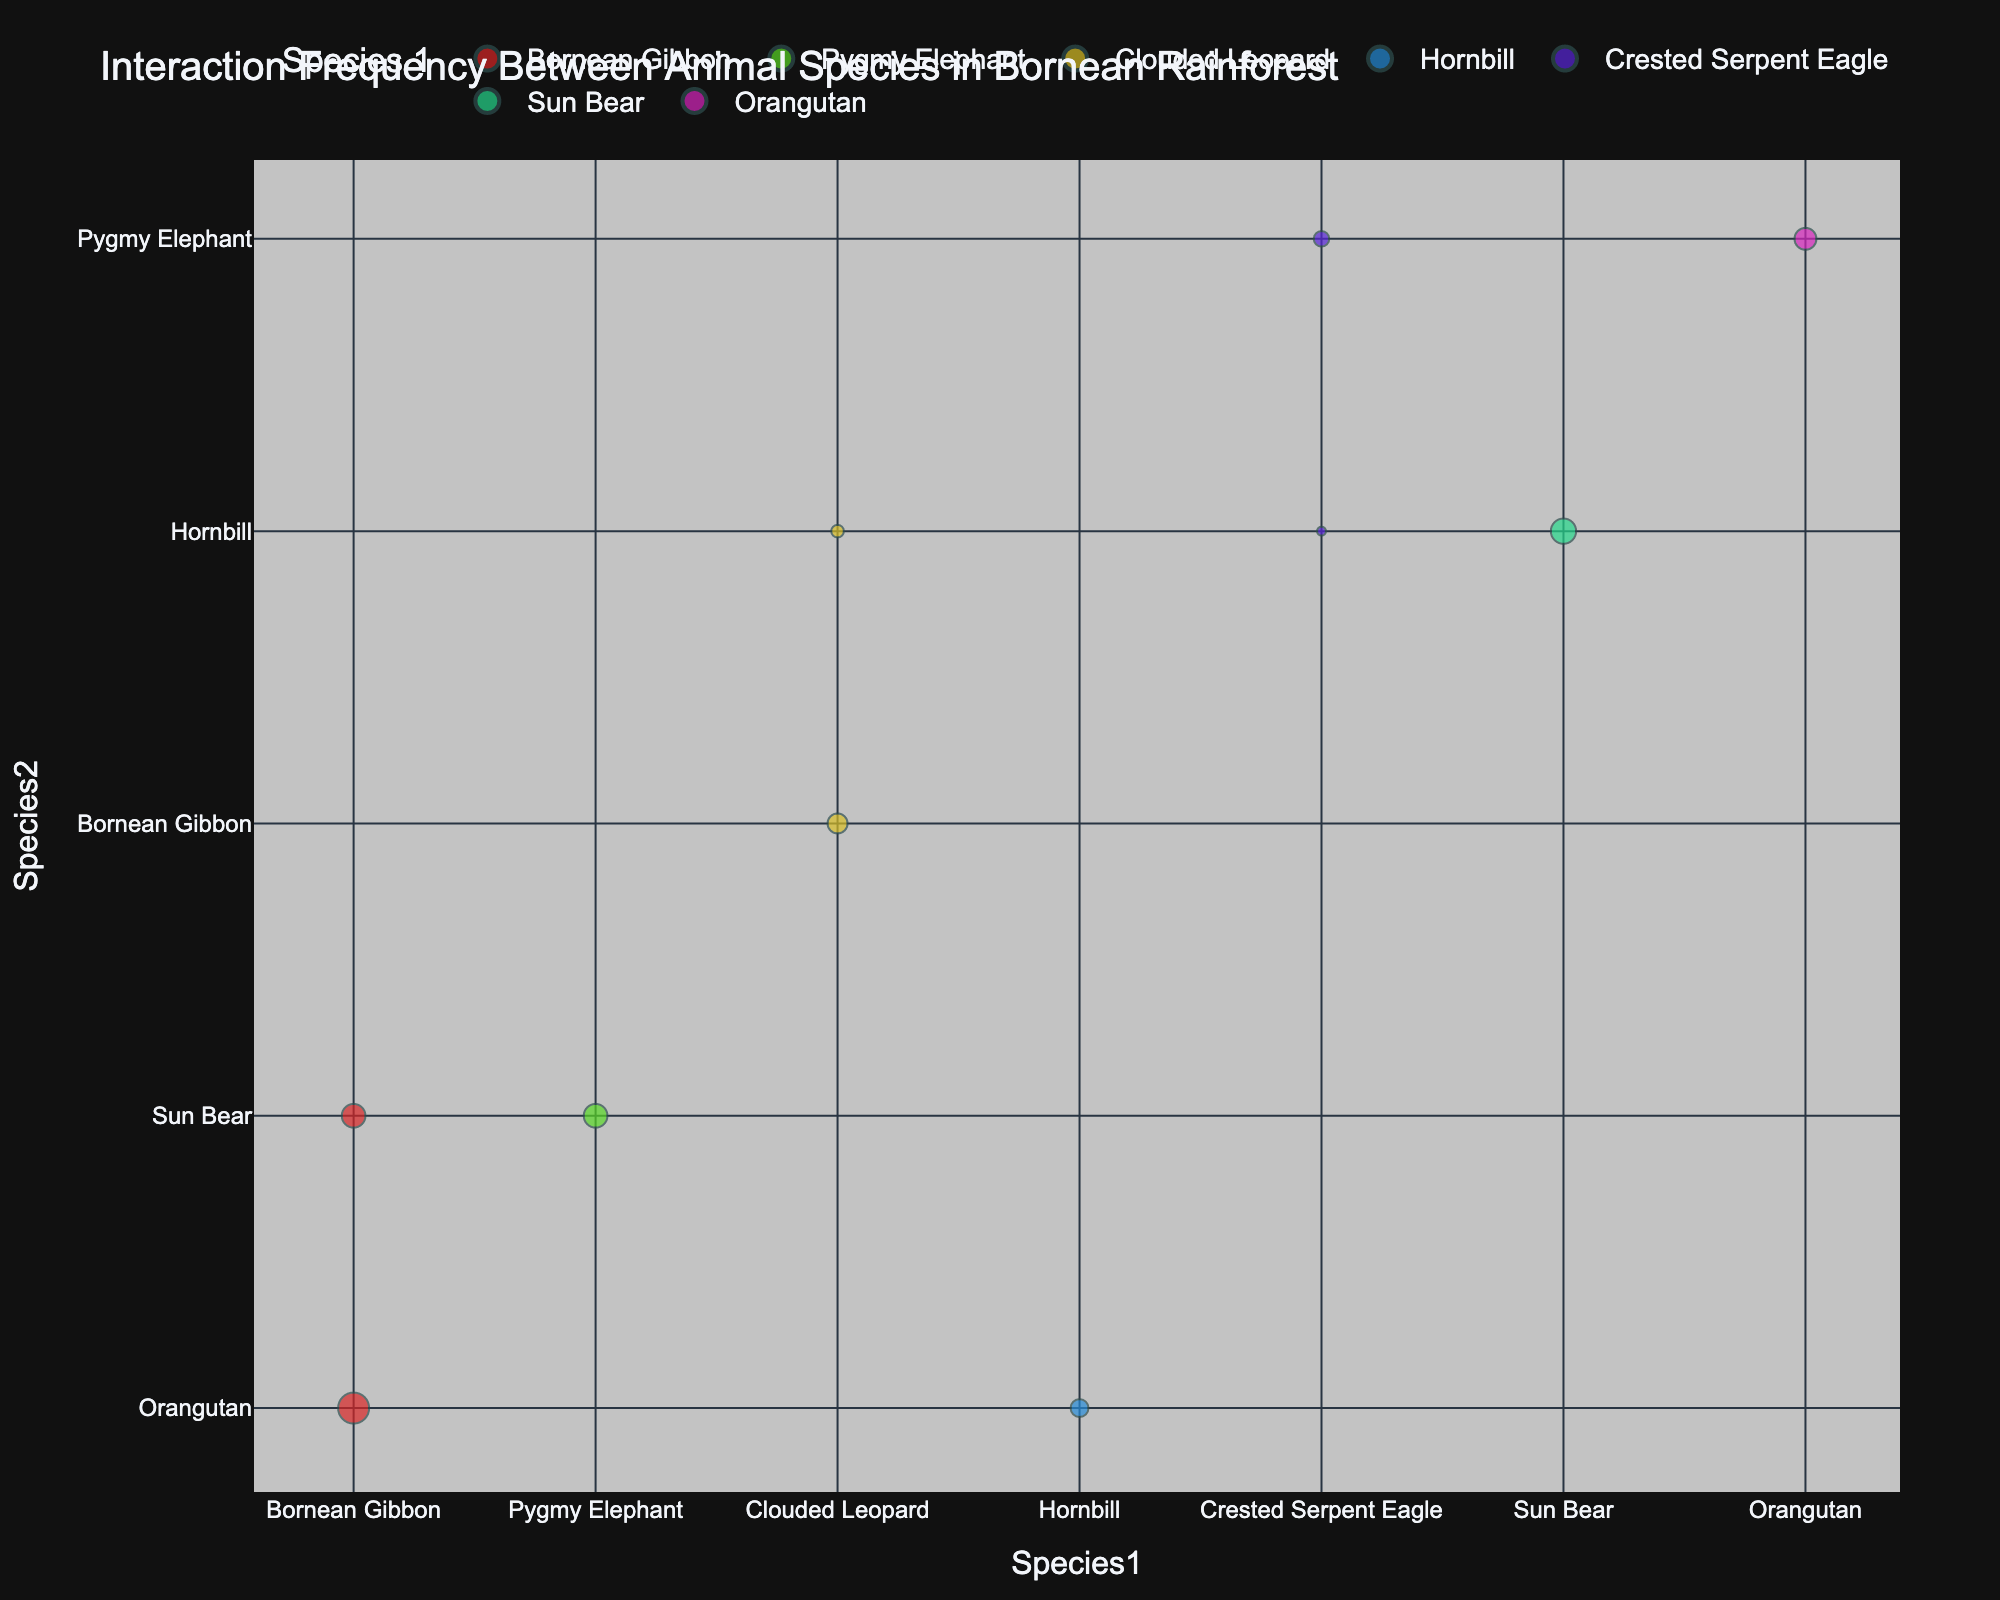What is the title of the chart? The title of the chart is displayed at the top. By looking at the top of the figure, you can see it clearly. It reads "Interaction Frequency Between Animal Species in Bornean Rainforest."
Answer: Interaction Frequency Between Animal Species in Bornean Rainforest How many different species are represented in total? To determine the number of different species, you can count the unique species names from both columns 'Species1' and 'Species2'. The species are Bornean Gibbon, Orangutan, Pygmy Elephant, Sun Bear, Clouded Leopard, Hornbill, and Crested Serpent Eagle, totaling 7 unique species.
Answer: 7 Which pair of species has the highest interaction frequency? Find the largest bubble on the chart to identify the pair with the highest interaction frequency. The largest bubble represents the Bornean Gibbon and Orangutan with an interaction frequency of 12.
Answer: Bornean Gibbon and Orangutan Which ecosystem is mentioned in the chart? According to the hover data labels seen on the bubbles, the ecosystem mentioned in the chart is the Borneo Rainforest.
Answer: Borneo Rainforest What is the interaction frequency between Clouded Leopard and Hornbill? Locate the bubble for the pair Clouded Leopard and Hornbill on the chart and check the size, which represents their interaction frequency. The interaction frequency for this pair is 2.
Answer: 2 What is the sum of interaction frequencies for pairs involving the Sun Bear? Identify all of the bubbles involving Sun Bear: Sun Bear and Pygmy Elephant (7), Sun Bear and Hornbill (8), and Sun Bear and Bornean Gibbon (7). Sum these values to get the total: 7 + 8 + 7 = 22.
Answer: 22 Which pair has a higher interaction frequency: Sun Bear and Hornbill or Orangutan and Pygmy Elephant? Compare the sizes of the two bubbles for Sun Bear and Hornbill (8) with that of Orangutan and Pygmy Elephant (6). The interaction frequency of Sun Bear and Hornbill is higher.
Answer: Sun Bear and Hornbill How many unique pairs of species are represented in the chart? Count each unique bubble on the chart, representing distinct pairs of species interactions. The chart has 10 different pairs.
Answer: 10 Which has the least interaction frequency: Crested Serpent Eagle and Hornbill or Crested Serpent Eagle and Pygmy Elephant? Compare the bubbles for Crested Serpent Eagle and Hornbill (1) with Crested Serpent Eagle and Pygmy Elephant (3). The interaction frequency of Crested Serpent Eagle and Hornbill is less.
Answer: Crested Serpent Eagle and Hornbill 